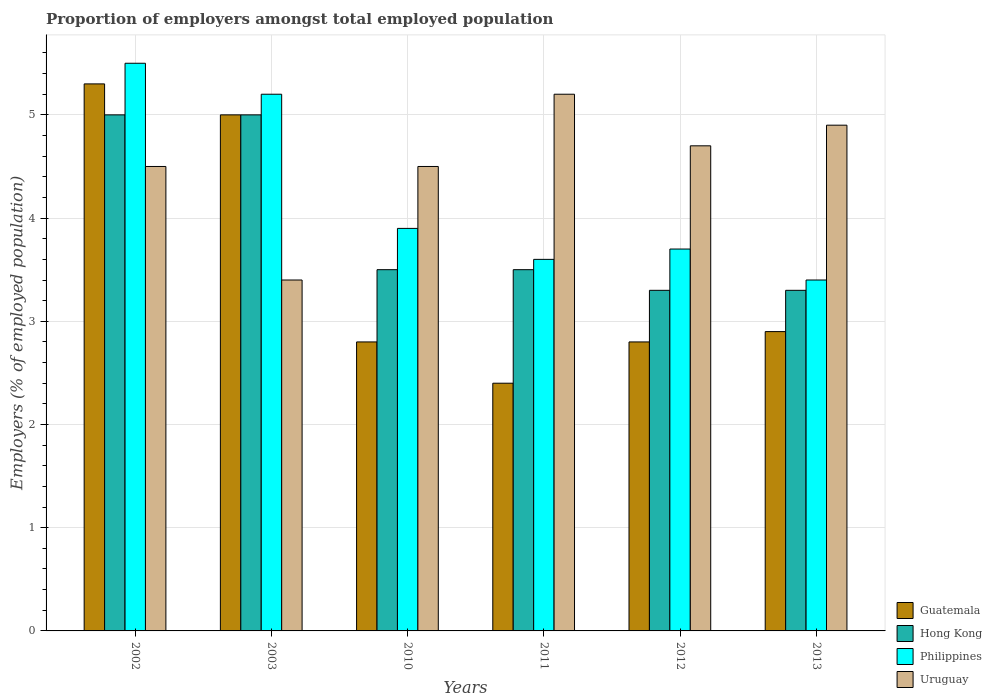How many different coloured bars are there?
Your response must be concise. 4. Are the number of bars per tick equal to the number of legend labels?
Make the answer very short. Yes. How many bars are there on the 2nd tick from the left?
Make the answer very short. 4. What is the label of the 1st group of bars from the left?
Offer a very short reply. 2002. What is the proportion of employers in Guatemala in 2003?
Provide a short and direct response. 5. Across all years, what is the maximum proportion of employers in Philippines?
Offer a terse response. 5.5. Across all years, what is the minimum proportion of employers in Philippines?
Ensure brevity in your answer.  3.4. What is the total proportion of employers in Uruguay in the graph?
Make the answer very short. 27.2. What is the difference between the proportion of employers in Philippines in 2002 and that in 2012?
Keep it short and to the point. 1.8. What is the difference between the proportion of employers in Uruguay in 2003 and the proportion of employers in Guatemala in 2002?
Give a very brief answer. -1.9. What is the average proportion of employers in Hong Kong per year?
Offer a very short reply. 3.93. In the year 2011, what is the difference between the proportion of employers in Philippines and proportion of employers in Uruguay?
Your answer should be very brief. -1.6. What is the ratio of the proportion of employers in Philippines in 2010 to that in 2011?
Your response must be concise. 1.08. What is the difference between the highest and the second highest proportion of employers in Guatemala?
Keep it short and to the point. 0.3. What is the difference between the highest and the lowest proportion of employers in Philippines?
Make the answer very short. 2.1. In how many years, is the proportion of employers in Uruguay greater than the average proportion of employers in Uruguay taken over all years?
Make the answer very short. 3. Is it the case that in every year, the sum of the proportion of employers in Guatemala and proportion of employers in Philippines is greater than the sum of proportion of employers in Hong Kong and proportion of employers in Uruguay?
Ensure brevity in your answer.  No. What does the 2nd bar from the left in 2003 represents?
Your answer should be very brief. Hong Kong. What does the 1st bar from the right in 2011 represents?
Give a very brief answer. Uruguay. How many years are there in the graph?
Offer a very short reply. 6. What is the difference between two consecutive major ticks on the Y-axis?
Your response must be concise. 1. Are the values on the major ticks of Y-axis written in scientific E-notation?
Provide a succinct answer. No. Does the graph contain any zero values?
Your answer should be very brief. No. Does the graph contain grids?
Your response must be concise. Yes. Where does the legend appear in the graph?
Provide a succinct answer. Bottom right. How many legend labels are there?
Keep it short and to the point. 4. What is the title of the graph?
Keep it short and to the point. Proportion of employers amongst total employed population. What is the label or title of the X-axis?
Make the answer very short. Years. What is the label or title of the Y-axis?
Provide a short and direct response. Employers (% of employed population). What is the Employers (% of employed population) of Guatemala in 2002?
Make the answer very short. 5.3. What is the Employers (% of employed population) in Hong Kong in 2002?
Give a very brief answer. 5. What is the Employers (% of employed population) of Guatemala in 2003?
Your answer should be very brief. 5. What is the Employers (% of employed population) of Philippines in 2003?
Give a very brief answer. 5.2. What is the Employers (% of employed population) in Uruguay in 2003?
Ensure brevity in your answer.  3.4. What is the Employers (% of employed population) in Guatemala in 2010?
Offer a terse response. 2.8. What is the Employers (% of employed population) of Philippines in 2010?
Your answer should be very brief. 3.9. What is the Employers (% of employed population) in Guatemala in 2011?
Offer a very short reply. 2.4. What is the Employers (% of employed population) in Philippines in 2011?
Keep it short and to the point. 3.6. What is the Employers (% of employed population) of Uruguay in 2011?
Keep it short and to the point. 5.2. What is the Employers (% of employed population) of Guatemala in 2012?
Provide a short and direct response. 2.8. What is the Employers (% of employed population) of Hong Kong in 2012?
Make the answer very short. 3.3. What is the Employers (% of employed population) in Philippines in 2012?
Offer a very short reply. 3.7. What is the Employers (% of employed population) of Uruguay in 2012?
Provide a short and direct response. 4.7. What is the Employers (% of employed population) of Guatemala in 2013?
Your response must be concise. 2.9. What is the Employers (% of employed population) in Hong Kong in 2013?
Your response must be concise. 3.3. What is the Employers (% of employed population) in Philippines in 2013?
Offer a very short reply. 3.4. What is the Employers (% of employed population) in Uruguay in 2013?
Provide a short and direct response. 4.9. Across all years, what is the maximum Employers (% of employed population) of Guatemala?
Your answer should be compact. 5.3. Across all years, what is the maximum Employers (% of employed population) of Hong Kong?
Provide a succinct answer. 5. Across all years, what is the maximum Employers (% of employed population) in Uruguay?
Your response must be concise. 5.2. Across all years, what is the minimum Employers (% of employed population) in Guatemala?
Make the answer very short. 2.4. Across all years, what is the minimum Employers (% of employed population) in Hong Kong?
Offer a terse response. 3.3. Across all years, what is the minimum Employers (% of employed population) of Philippines?
Your answer should be very brief. 3.4. Across all years, what is the minimum Employers (% of employed population) in Uruguay?
Offer a very short reply. 3.4. What is the total Employers (% of employed population) in Guatemala in the graph?
Ensure brevity in your answer.  21.2. What is the total Employers (% of employed population) of Hong Kong in the graph?
Your answer should be compact. 23.6. What is the total Employers (% of employed population) in Philippines in the graph?
Your answer should be very brief. 25.3. What is the total Employers (% of employed population) of Uruguay in the graph?
Give a very brief answer. 27.2. What is the difference between the Employers (% of employed population) in Philippines in 2002 and that in 2003?
Offer a terse response. 0.3. What is the difference between the Employers (% of employed population) of Uruguay in 2002 and that in 2003?
Offer a very short reply. 1.1. What is the difference between the Employers (% of employed population) in Guatemala in 2002 and that in 2010?
Your response must be concise. 2.5. What is the difference between the Employers (% of employed population) of Hong Kong in 2002 and that in 2010?
Your answer should be compact. 1.5. What is the difference between the Employers (% of employed population) of Philippines in 2002 and that in 2010?
Offer a very short reply. 1.6. What is the difference between the Employers (% of employed population) in Uruguay in 2002 and that in 2010?
Give a very brief answer. 0. What is the difference between the Employers (% of employed population) in Guatemala in 2002 and that in 2011?
Offer a terse response. 2.9. What is the difference between the Employers (% of employed population) in Hong Kong in 2002 and that in 2011?
Keep it short and to the point. 1.5. What is the difference between the Employers (% of employed population) of Philippines in 2002 and that in 2012?
Keep it short and to the point. 1.8. What is the difference between the Employers (% of employed population) of Uruguay in 2002 and that in 2012?
Make the answer very short. -0.2. What is the difference between the Employers (% of employed population) of Hong Kong in 2002 and that in 2013?
Keep it short and to the point. 1.7. What is the difference between the Employers (% of employed population) of Philippines in 2002 and that in 2013?
Give a very brief answer. 2.1. What is the difference between the Employers (% of employed population) in Uruguay in 2003 and that in 2010?
Offer a terse response. -1.1. What is the difference between the Employers (% of employed population) in Uruguay in 2003 and that in 2011?
Provide a succinct answer. -1.8. What is the difference between the Employers (% of employed population) in Guatemala in 2003 and that in 2012?
Ensure brevity in your answer.  2.2. What is the difference between the Employers (% of employed population) of Hong Kong in 2003 and that in 2012?
Provide a succinct answer. 1.7. What is the difference between the Employers (% of employed population) of Uruguay in 2003 and that in 2012?
Give a very brief answer. -1.3. What is the difference between the Employers (% of employed population) of Philippines in 2003 and that in 2013?
Your response must be concise. 1.8. What is the difference between the Employers (% of employed population) in Uruguay in 2003 and that in 2013?
Offer a terse response. -1.5. What is the difference between the Employers (% of employed population) in Hong Kong in 2010 and that in 2011?
Your answer should be compact. 0. What is the difference between the Employers (% of employed population) of Philippines in 2010 and that in 2011?
Make the answer very short. 0.3. What is the difference between the Employers (% of employed population) in Uruguay in 2010 and that in 2011?
Provide a short and direct response. -0.7. What is the difference between the Employers (% of employed population) in Philippines in 2010 and that in 2012?
Offer a very short reply. 0.2. What is the difference between the Employers (% of employed population) in Uruguay in 2010 and that in 2012?
Make the answer very short. -0.2. What is the difference between the Employers (% of employed population) in Guatemala in 2010 and that in 2013?
Provide a short and direct response. -0.1. What is the difference between the Employers (% of employed population) of Hong Kong in 2011 and that in 2012?
Provide a short and direct response. 0.2. What is the difference between the Employers (% of employed population) of Philippines in 2011 and that in 2012?
Ensure brevity in your answer.  -0.1. What is the difference between the Employers (% of employed population) in Guatemala in 2011 and that in 2013?
Your answer should be very brief. -0.5. What is the difference between the Employers (% of employed population) of Guatemala in 2012 and that in 2013?
Your answer should be compact. -0.1. What is the difference between the Employers (% of employed population) in Hong Kong in 2012 and that in 2013?
Offer a terse response. 0. What is the difference between the Employers (% of employed population) in Philippines in 2012 and that in 2013?
Provide a succinct answer. 0.3. What is the difference between the Employers (% of employed population) in Uruguay in 2012 and that in 2013?
Your answer should be very brief. -0.2. What is the difference between the Employers (% of employed population) in Hong Kong in 2002 and the Employers (% of employed population) in Uruguay in 2010?
Offer a terse response. 0.5. What is the difference between the Employers (% of employed population) of Philippines in 2002 and the Employers (% of employed population) of Uruguay in 2010?
Give a very brief answer. 1. What is the difference between the Employers (% of employed population) of Guatemala in 2002 and the Employers (% of employed population) of Hong Kong in 2011?
Offer a very short reply. 1.8. What is the difference between the Employers (% of employed population) in Guatemala in 2002 and the Employers (% of employed population) in Philippines in 2011?
Ensure brevity in your answer.  1.7. What is the difference between the Employers (% of employed population) in Hong Kong in 2002 and the Employers (% of employed population) in Philippines in 2011?
Give a very brief answer. 1.4. What is the difference between the Employers (% of employed population) in Guatemala in 2002 and the Employers (% of employed population) in Uruguay in 2012?
Your response must be concise. 0.6. What is the difference between the Employers (% of employed population) in Hong Kong in 2002 and the Employers (% of employed population) in Philippines in 2012?
Make the answer very short. 1.3. What is the difference between the Employers (% of employed population) of Guatemala in 2002 and the Employers (% of employed population) of Hong Kong in 2013?
Keep it short and to the point. 2. What is the difference between the Employers (% of employed population) of Guatemala in 2002 and the Employers (% of employed population) of Uruguay in 2013?
Provide a succinct answer. 0.4. What is the difference between the Employers (% of employed population) of Hong Kong in 2002 and the Employers (% of employed population) of Philippines in 2013?
Ensure brevity in your answer.  1.6. What is the difference between the Employers (% of employed population) in Hong Kong in 2002 and the Employers (% of employed population) in Uruguay in 2013?
Offer a very short reply. 0.1. What is the difference between the Employers (% of employed population) of Guatemala in 2003 and the Employers (% of employed population) of Hong Kong in 2010?
Your answer should be very brief. 1.5. What is the difference between the Employers (% of employed population) in Philippines in 2003 and the Employers (% of employed population) in Uruguay in 2010?
Offer a very short reply. 0.7. What is the difference between the Employers (% of employed population) of Hong Kong in 2003 and the Employers (% of employed population) of Philippines in 2011?
Keep it short and to the point. 1.4. What is the difference between the Employers (% of employed population) of Hong Kong in 2003 and the Employers (% of employed population) of Uruguay in 2011?
Keep it short and to the point. -0.2. What is the difference between the Employers (% of employed population) in Philippines in 2003 and the Employers (% of employed population) in Uruguay in 2011?
Ensure brevity in your answer.  0. What is the difference between the Employers (% of employed population) in Guatemala in 2003 and the Employers (% of employed population) in Philippines in 2012?
Provide a succinct answer. 1.3. What is the difference between the Employers (% of employed population) in Guatemala in 2003 and the Employers (% of employed population) in Uruguay in 2012?
Provide a short and direct response. 0.3. What is the difference between the Employers (% of employed population) of Hong Kong in 2003 and the Employers (% of employed population) of Uruguay in 2012?
Your answer should be compact. 0.3. What is the difference between the Employers (% of employed population) of Hong Kong in 2003 and the Employers (% of employed population) of Philippines in 2013?
Ensure brevity in your answer.  1.6. What is the difference between the Employers (% of employed population) in Guatemala in 2010 and the Employers (% of employed population) in Uruguay in 2011?
Offer a terse response. -2.4. What is the difference between the Employers (% of employed population) in Hong Kong in 2010 and the Employers (% of employed population) in Philippines in 2011?
Offer a very short reply. -0.1. What is the difference between the Employers (% of employed population) of Guatemala in 2010 and the Employers (% of employed population) of Philippines in 2012?
Keep it short and to the point. -0.9. What is the difference between the Employers (% of employed population) in Guatemala in 2010 and the Employers (% of employed population) in Uruguay in 2012?
Your response must be concise. -1.9. What is the difference between the Employers (% of employed population) of Hong Kong in 2010 and the Employers (% of employed population) of Philippines in 2012?
Keep it short and to the point. -0.2. What is the difference between the Employers (% of employed population) of Hong Kong in 2010 and the Employers (% of employed population) of Uruguay in 2012?
Provide a short and direct response. -1.2. What is the difference between the Employers (% of employed population) in Philippines in 2010 and the Employers (% of employed population) in Uruguay in 2012?
Offer a very short reply. -0.8. What is the difference between the Employers (% of employed population) in Guatemala in 2010 and the Employers (% of employed population) in Philippines in 2013?
Provide a short and direct response. -0.6. What is the difference between the Employers (% of employed population) of Guatemala in 2010 and the Employers (% of employed population) of Uruguay in 2013?
Your response must be concise. -2.1. What is the difference between the Employers (% of employed population) of Hong Kong in 2010 and the Employers (% of employed population) of Uruguay in 2013?
Offer a terse response. -1.4. What is the difference between the Employers (% of employed population) in Philippines in 2010 and the Employers (% of employed population) in Uruguay in 2013?
Keep it short and to the point. -1. What is the difference between the Employers (% of employed population) of Guatemala in 2011 and the Employers (% of employed population) of Hong Kong in 2012?
Offer a very short reply. -0.9. What is the difference between the Employers (% of employed population) in Hong Kong in 2011 and the Employers (% of employed population) in Uruguay in 2012?
Offer a terse response. -1.2. What is the difference between the Employers (% of employed population) of Philippines in 2011 and the Employers (% of employed population) of Uruguay in 2012?
Offer a terse response. -1.1. What is the difference between the Employers (% of employed population) in Guatemala in 2011 and the Employers (% of employed population) in Philippines in 2013?
Make the answer very short. -1. What is the difference between the Employers (% of employed population) in Hong Kong in 2011 and the Employers (% of employed population) in Philippines in 2013?
Make the answer very short. 0.1. What is the difference between the Employers (% of employed population) in Guatemala in 2012 and the Employers (% of employed population) in Philippines in 2013?
Your response must be concise. -0.6. What is the difference between the Employers (% of employed population) of Guatemala in 2012 and the Employers (% of employed population) of Uruguay in 2013?
Your response must be concise. -2.1. What is the difference between the Employers (% of employed population) of Hong Kong in 2012 and the Employers (% of employed population) of Uruguay in 2013?
Your answer should be very brief. -1.6. What is the average Employers (% of employed population) in Guatemala per year?
Ensure brevity in your answer.  3.53. What is the average Employers (% of employed population) in Hong Kong per year?
Make the answer very short. 3.93. What is the average Employers (% of employed population) of Philippines per year?
Give a very brief answer. 4.22. What is the average Employers (% of employed population) in Uruguay per year?
Offer a very short reply. 4.53. In the year 2002, what is the difference between the Employers (% of employed population) in Guatemala and Employers (% of employed population) in Hong Kong?
Ensure brevity in your answer.  0.3. In the year 2002, what is the difference between the Employers (% of employed population) of Guatemala and Employers (% of employed population) of Philippines?
Give a very brief answer. -0.2. In the year 2002, what is the difference between the Employers (% of employed population) of Hong Kong and Employers (% of employed population) of Uruguay?
Your answer should be very brief. 0.5. In the year 2003, what is the difference between the Employers (% of employed population) in Guatemala and Employers (% of employed population) in Philippines?
Ensure brevity in your answer.  -0.2. In the year 2003, what is the difference between the Employers (% of employed population) in Philippines and Employers (% of employed population) in Uruguay?
Offer a terse response. 1.8. In the year 2010, what is the difference between the Employers (% of employed population) in Guatemala and Employers (% of employed population) in Philippines?
Offer a terse response. -1.1. In the year 2010, what is the difference between the Employers (% of employed population) of Hong Kong and Employers (% of employed population) of Philippines?
Your answer should be very brief. -0.4. In the year 2010, what is the difference between the Employers (% of employed population) of Philippines and Employers (% of employed population) of Uruguay?
Keep it short and to the point. -0.6. In the year 2011, what is the difference between the Employers (% of employed population) in Hong Kong and Employers (% of employed population) in Uruguay?
Ensure brevity in your answer.  -1.7. In the year 2011, what is the difference between the Employers (% of employed population) of Philippines and Employers (% of employed population) of Uruguay?
Give a very brief answer. -1.6. In the year 2012, what is the difference between the Employers (% of employed population) in Hong Kong and Employers (% of employed population) in Philippines?
Your answer should be very brief. -0.4. In the year 2012, what is the difference between the Employers (% of employed population) in Hong Kong and Employers (% of employed population) in Uruguay?
Offer a very short reply. -1.4. In the year 2012, what is the difference between the Employers (% of employed population) in Philippines and Employers (% of employed population) in Uruguay?
Your response must be concise. -1. In the year 2013, what is the difference between the Employers (% of employed population) in Guatemala and Employers (% of employed population) in Hong Kong?
Provide a succinct answer. -0.4. In the year 2013, what is the difference between the Employers (% of employed population) in Guatemala and Employers (% of employed population) in Philippines?
Offer a very short reply. -0.5. In the year 2013, what is the difference between the Employers (% of employed population) in Guatemala and Employers (% of employed population) in Uruguay?
Ensure brevity in your answer.  -2. In the year 2013, what is the difference between the Employers (% of employed population) in Hong Kong and Employers (% of employed population) in Philippines?
Make the answer very short. -0.1. In the year 2013, what is the difference between the Employers (% of employed population) in Hong Kong and Employers (% of employed population) in Uruguay?
Provide a short and direct response. -1.6. In the year 2013, what is the difference between the Employers (% of employed population) in Philippines and Employers (% of employed population) in Uruguay?
Give a very brief answer. -1.5. What is the ratio of the Employers (% of employed population) of Guatemala in 2002 to that in 2003?
Make the answer very short. 1.06. What is the ratio of the Employers (% of employed population) of Hong Kong in 2002 to that in 2003?
Offer a terse response. 1. What is the ratio of the Employers (% of employed population) of Philippines in 2002 to that in 2003?
Your answer should be compact. 1.06. What is the ratio of the Employers (% of employed population) in Uruguay in 2002 to that in 2003?
Provide a succinct answer. 1.32. What is the ratio of the Employers (% of employed population) of Guatemala in 2002 to that in 2010?
Your answer should be very brief. 1.89. What is the ratio of the Employers (% of employed population) in Hong Kong in 2002 to that in 2010?
Ensure brevity in your answer.  1.43. What is the ratio of the Employers (% of employed population) in Philippines in 2002 to that in 2010?
Your answer should be compact. 1.41. What is the ratio of the Employers (% of employed population) in Guatemala in 2002 to that in 2011?
Offer a terse response. 2.21. What is the ratio of the Employers (% of employed population) in Hong Kong in 2002 to that in 2011?
Your answer should be compact. 1.43. What is the ratio of the Employers (% of employed population) of Philippines in 2002 to that in 2011?
Provide a succinct answer. 1.53. What is the ratio of the Employers (% of employed population) of Uruguay in 2002 to that in 2011?
Keep it short and to the point. 0.87. What is the ratio of the Employers (% of employed population) of Guatemala in 2002 to that in 2012?
Offer a terse response. 1.89. What is the ratio of the Employers (% of employed population) in Hong Kong in 2002 to that in 2012?
Provide a short and direct response. 1.52. What is the ratio of the Employers (% of employed population) in Philippines in 2002 to that in 2012?
Offer a very short reply. 1.49. What is the ratio of the Employers (% of employed population) of Uruguay in 2002 to that in 2012?
Offer a terse response. 0.96. What is the ratio of the Employers (% of employed population) of Guatemala in 2002 to that in 2013?
Offer a very short reply. 1.83. What is the ratio of the Employers (% of employed population) of Hong Kong in 2002 to that in 2013?
Keep it short and to the point. 1.52. What is the ratio of the Employers (% of employed population) in Philippines in 2002 to that in 2013?
Provide a short and direct response. 1.62. What is the ratio of the Employers (% of employed population) of Uruguay in 2002 to that in 2013?
Your response must be concise. 0.92. What is the ratio of the Employers (% of employed population) in Guatemala in 2003 to that in 2010?
Your response must be concise. 1.79. What is the ratio of the Employers (% of employed population) in Hong Kong in 2003 to that in 2010?
Your answer should be compact. 1.43. What is the ratio of the Employers (% of employed population) in Philippines in 2003 to that in 2010?
Make the answer very short. 1.33. What is the ratio of the Employers (% of employed population) in Uruguay in 2003 to that in 2010?
Your answer should be very brief. 0.76. What is the ratio of the Employers (% of employed population) of Guatemala in 2003 to that in 2011?
Make the answer very short. 2.08. What is the ratio of the Employers (% of employed population) of Hong Kong in 2003 to that in 2011?
Your response must be concise. 1.43. What is the ratio of the Employers (% of employed population) of Philippines in 2003 to that in 2011?
Make the answer very short. 1.44. What is the ratio of the Employers (% of employed population) in Uruguay in 2003 to that in 2011?
Keep it short and to the point. 0.65. What is the ratio of the Employers (% of employed population) of Guatemala in 2003 to that in 2012?
Offer a very short reply. 1.79. What is the ratio of the Employers (% of employed population) of Hong Kong in 2003 to that in 2012?
Make the answer very short. 1.52. What is the ratio of the Employers (% of employed population) in Philippines in 2003 to that in 2012?
Provide a short and direct response. 1.41. What is the ratio of the Employers (% of employed population) in Uruguay in 2003 to that in 2012?
Offer a terse response. 0.72. What is the ratio of the Employers (% of employed population) in Guatemala in 2003 to that in 2013?
Offer a terse response. 1.72. What is the ratio of the Employers (% of employed population) in Hong Kong in 2003 to that in 2013?
Ensure brevity in your answer.  1.52. What is the ratio of the Employers (% of employed population) in Philippines in 2003 to that in 2013?
Offer a very short reply. 1.53. What is the ratio of the Employers (% of employed population) in Uruguay in 2003 to that in 2013?
Keep it short and to the point. 0.69. What is the ratio of the Employers (% of employed population) in Guatemala in 2010 to that in 2011?
Offer a terse response. 1.17. What is the ratio of the Employers (% of employed population) in Philippines in 2010 to that in 2011?
Keep it short and to the point. 1.08. What is the ratio of the Employers (% of employed population) of Uruguay in 2010 to that in 2011?
Offer a very short reply. 0.87. What is the ratio of the Employers (% of employed population) of Hong Kong in 2010 to that in 2012?
Keep it short and to the point. 1.06. What is the ratio of the Employers (% of employed population) in Philippines in 2010 to that in 2012?
Give a very brief answer. 1.05. What is the ratio of the Employers (% of employed population) of Uruguay in 2010 to that in 2012?
Offer a terse response. 0.96. What is the ratio of the Employers (% of employed population) in Guatemala in 2010 to that in 2013?
Offer a very short reply. 0.97. What is the ratio of the Employers (% of employed population) of Hong Kong in 2010 to that in 2013?
Provide a short and direct response. 1.06. What is the ratio of the Employers (% of employed population) in Philippines in 2010 to that in 2013?
Offer a very short reply. 1.15. What is the ratio of the Employers (% of employed population) in Uruguay in 2010 to that in 2013?
Offer a very short reply. 0.92. What is the ratio of the Employers (% of employed population) in Guatemala in 2011 to that in 2012?
Give a very brief answer. 0.86. What is the ratio of the Employers (% of employed population) in Hong Kong in 2011 to that in 2012?
Provide a short and direct response. 1.06. What is the ratio of the Employers (% of employed population) in Uruguay in 2011 to that in 2012?
Give a very brief answer. 1.11. What is the ratio of the Employers (% of employed population) of Guatemala in 2011 to that in 2013?
Offer a terse response. 0.83. What is the ratio of the Employers (% of employed population) in Hong Kong in 2011 to that in 2013?
Your answer should be very brief. 1.06. What is the ratio of the Employers (% of employed population) in Philippines in 2011 to that in 2013?
Your response must be concise. 1.06. What is the ratio of the Employers (% of employed population) of Uruguay in 2011 to that in 2013?
Your answer should be compact. 1.06. What is the ratio of the Employers (% of employed population) in Guatemala in 2012 to that in 2013?
Your answer should be compact. 0.97. What is the ratio of the Employers (% of employed population) in Philippines in 2012 to that in 2013?
Offer a terse response. 1.09. What is the ratio of the Employers (% of employed population) of Uruguay in 2012 to that in 2013?
Offer a very short reply. 0.96. What is the difference between the highest and the second highest Employers (% of employed population) of Guatemala?
Your response must be concise. 0.3. What is the difference between the highest and the second highest Employers (% of employed population) of Philippines?
Provide a succinct answer. 0.3. 